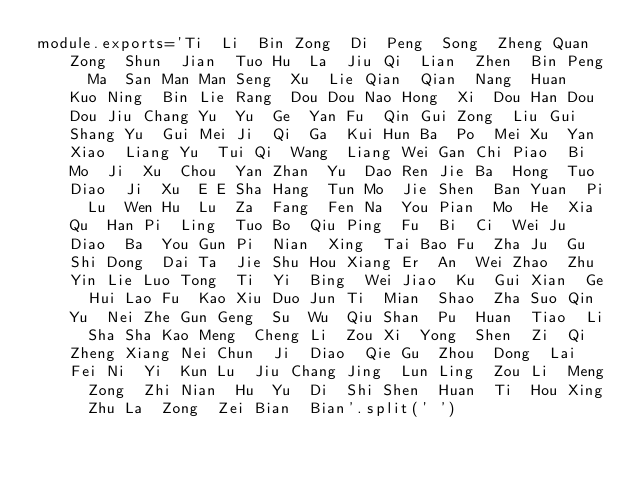Convert code to text. <code><loc_0><loc_0><loc_500><loc_500><_JavaScript_>module.exports='Ti	Li	Bin	Zong	Di	Peng	Song	Zheng	Quan	Zong	Shun	Jian	Tuo	Hu	La	Jiu	Qi	Lian	Zhen	Bin	Peng	Ma	San	Man	Man	Seng	Xu	Lie	Qian	Qian	Nang	Huan	Kuo	Ning	Bin	Lie	Rang	Dou	Dou	Nao	Hong	Xi	Dou	Han	Dou	Dou	Jiu	Chang	Yu	Yu	Ge	Yan	Fu	Qin	Gui	Zong	Liu	Gui	Shang	Yu	Gui	Mei	Ji	Qi	Ga	Kui	Hun	Ba	Po	Mei	Xu	Yan	Xiao	Liang	Yu	Tui	Qi	Wang	Liang	Wei	Gan	Chi	Piao	Bi	Mo	Ji	Xu	Chou	Yan	Zhan	Yu	Dao	Ren	Jie	Ba	Hong	Tuo	Diao	Ji	Xu	E	E	Sha	Hang	Tun	Mo	Jie	Shen	Ban	Yuan	Pi	Lu	Wen	Hu	Lu	Za	Fang	Fen	Na	You	Pian	Mo	He	Xia	Qu	Han	Pi	Ling	Tuo	Bo	Qiu	Ping	Fu	Bi	Ci	Wei	Ju	Diao	Ba	You	Gun	Pi	Nian	Xing	Tai	Bao	Fu	Zha	Ju	Gu	Shi	Dong	Dai	Ta	Jie	Shu	Hou	Xiang	Er	An	Wei	Zhao	Zhu	Yin	Lie	Luo	Tong	Ti	Yi	Bing	Wei	Jiao	Ku	Gui	Xian	Ge	Hui	Lao	Fu	Kao	Xiu	Duo	Jun	Ti	Mian	Shao	Zha	Suo	Qin	Yu	Nei	Zhe	Gun	Geng	Su	Wu	Qiu	Shan	Pu	Huan	Tiao	Li	Sha	Sha	Kao	Meng	Cheng	Li	Zou	Xi	Yong	Shen	Zi	Qi	Zheng	Xiang	Nei	Chun	Ji	Diao	Qie	Gu	Zhou	Dong	Lai	Fei	Ni	Yi	Kun	Lu	Jiu	Chang	Jing	Lun	Ling	Zou	Li	Meng	Zong	Zhi	Nian	Hu	Yu	Di	Shi	Shen	Huan	Ti	Hou	Xing	Zhu	La	Zong	Zei	Bian	Bian'.split('	')</code> 